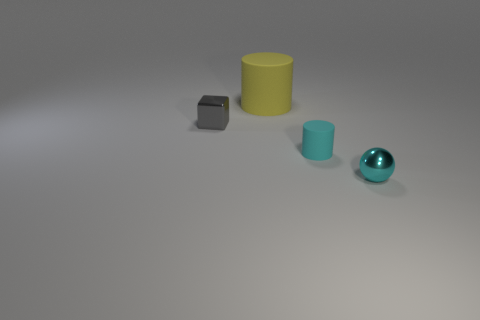Add 4 cyan metal cylinders. How many objects exist? 8 Subtract all balls. How many objects are left? 3 Add 3 small gray things. How many small gray things are left? 4 Add 3 big purple metallic objects. How many big purple metallic objects exist? 3 Subtract 1 gray cubes. How many objects are left? 3 Subtract all big brown metallic cylinders. Subtract all yellow matte objects. How many objects are left? 3 